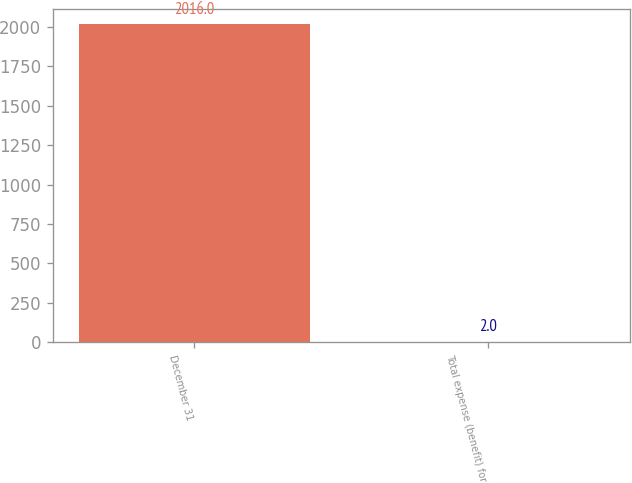Convert chart to OTSL. <chart><loc_0><loc_0><loc_500><loc_500><bar_chart><fcel>December 31<fcel>Total expense (benefit) for<nl><fcel>2016<fcel>2<nl></chart> 